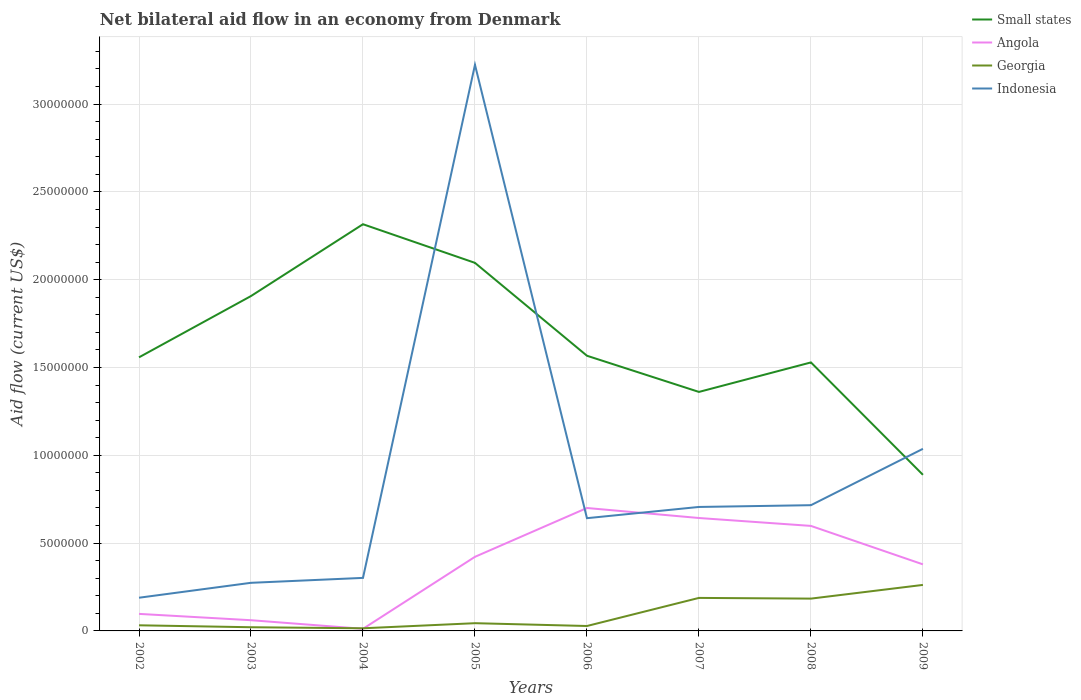Does the line corresponding to Angola intersect with the line corresponding to Small states?
Your answer should be compact. No. Across all years, what is the maximum net bilateral aid flow in Indonesia?
Provide a succinct answer. 1.89e+06. In which year was the net bilateral aid flow in Georgia maximum?
Provide a succinct answer. 2004. What is the total net bilateral aid flow in Angola in the graph?
Offer a very short reply. -5.86e+06. What is the difference between the highest and the second highest net bilateral aid flow in Indonesia?
Make the answer very short. 3.04e+07. How many lines are there?
Give a very brief answer. 4. How many years are there in the graph?
Give a very brief answer. 8. What is the difference between two consecutive major ticks on the Y-axis?
Provide a short and direct response. 5.00e+06. Does the graph contain grids?
Provide a succinct answer. Yes. What is the title of the graph?
Keep it short and to the point. Net bilateral aid flow in an economy from Denmark. Does "Comoros" appear as one of the legend labels in the graph?
Provide a short and direct response. No. What is the Aid flow (current US$) of Small states in 2002?
Ensure brevity in your answer.  1.56e+07. What is the Aid flow (current US$) of Angola in 2002?
Make the answer very short. 9.70e+05. What is the Aid flow (current US$) in Indonesia in 2002?
Your answer should be very brief. 1.89e+06. What is the Aid flow (current US$) in Small states in 2003?
Keep it short and to the point. 1.91e+07. What is the Aid flow (current US$) of Angola in 2003?
Your answer should be very brief. 6.10e+05. What is the Aid flow (current US$) of Georgia in 2003?
Offer a very short reply. 2.10e+05. What is the Aid flow (current US$) in Indonesia in 2003?
Offer a very short reply. 2.74e+06. What is the Aid flow (current US$) of Small states in 2004?
Keep it short and to the point. 2.32e+07. What is the Aid flow (current US$) of Angola in 2004?
Give a very brief answer. 1.20e+05. What is the Aid flow (current US$) in Georgia in 2004?
Provide a short and direct response. 1.50e+05. What is the Aid flow (current US$) of Indonesia in 2004?
Make the answer very short. 3.02e+06. What is the Aid flow (current US$) of Small states in 2005?
Your answer should be very brief. 2.10e+07. What is the Aid flow (current US$) in Angola in 2005?
Provide a short and direct response. 4.22e+06. What is the Aid flow (current US$) in Indonesia in 2005?
Ensure brevity in your answer.  3.22e+07. What is the Aid flow (current US$) in Small states in 2006?
Provide a short and direct response. 1.57e+07. What is the Aid flow (current US$) in Indonesia in 2006?
Provide a short and direct response. 6.42e+06. What is the Aid flow (current US$) of Small states in 2007?
Give a very brief answer. 1.36e+07. What is the Aid flow (current US$) of Angola in 2007?
Provide a short and direct response. 6.43e+06. What is the Aid flow (current US$) of Georgia in 2007?
Give a very brief answer. 1.88e+06. What is the Aid flow (current US$) of Indonesia in 2007?
Offer a terse response. 7.06e+06. What is the Aid flow (current US$) in Small states in 2008?
Provide a short and direct response. 1.53e+07. What is the Aid flow (current US$) of Angola in 2008?
Give a very brief answer. 5.98e+06. What is the Aid flow (current US$) in Georgia in 2008?
Provide a succinct answer. 1.84e+06. What is the Aid flow (current US$) of Indonesia in 2008?
Give a very brief answer. 7.16e+06. What is the Aid flow (current US$) in Small states in 2009?
Your answer should be very brief. 8.89e+06. What is the Aid flow (current US$) in Angola in 2009?
Provide a short and direct response. 3.79e+06. What is the Aid flow (current US$) of Georgia in 2009?
Your response must be concise. 2.62e+06. What is the Aid flow (current US$) of Indonesia in 2009?
Your answer should be very brief. 1.04e+07. Across all years, what is the maximum Aid flow (current US$) of Small states?
Provide a short and direct response. 2.32e+07. Across all years, what is the maximum Aid flow (current US$) of Angola?
Provide a succinct answer. 7.00e+06. Across all years, what is the maximum Aid flow (current US$) in Georgia?
Keep it short and to the point. 2.62e+06. Across all years, what is the maximum Aid flow (current US$) of Indonesia?
Your answer should be very brief. 3.22e+07. Across all years, what is the minimum Aid flow (current US$) in Small states?
Offer a very short reply. 8.89e+06. Across all years, what is the minimum Aid flow (current US$) in Angola?
Provide a short and direct response. 1.20e+05. Across all years, what is the minimum Aid flow (current US$) in Georgia?
Provide a succinct answer. 1.50e+05. Across all years, what is the minimum Aid flow (current US$) of Indonesia?
Your answer should be compact. 1.89e+06. What is the total Aid flow (current US$) of Small states in the graph?
Your answer should be very brief. 1.32e+08. What is the total Aid flow (current US$) in Angola in the graph?
Your answer should be very brief. 2.91e+07. What is the total Aid flow (current US$) of Georgia in the graph?
Provide a succinct answer. 7.74e+06. What is the total Aid flow (current US$) of Indonesia in the graph?
Keep it short and to the point. 7.09e+07. What is the difference between the Aid flow (current US$) of Small states in 2002 and that in 2003?
Your response must be concise. -3.49e+06. What is the difference between the Aid flow (current US$) of Georgia in 2002 and that in 2003?
Your answer should be compact. 1.10e+05. What is the difference between the Aid flow (current US$) of Indonesia in 2002 and that in 2003?
Give a very brief answer. -8.50e+05. What is the difference between the Aid flow (current US$) in Small states in 2002 and that in 2004?
Give a very brief answer. -7.58e+06. What is the difference between the Aid flow (current US$) of Angola in 2002 and that in 2004?
Offer a terse response. 8.50e+05. What is the difference between the Aid flow (current US$) of Georgia in 2002 and that in 2004?
Your answer should be very brief. 1.70e+05. What is the difference between the Aid flow (current US$) of Indonesia in 2002 and that in 2004?
Your response must be concise. -1.13e+06. What is the difference between the Aid flow (current US$) of Small states in 2002 and that in 2005?
Provide a succinct answer. -5.38e+06. What is the difference between the Aid flow (current US$) of Angola in 2002 and that in 2005?
Offer a very short reply. -3.25e+06. What is the difference between the Aid flow (current US$) of Georgia in 2002 and that in 2005?
Offer a very short reply. -1.20e+05. What is the difference between the Aid flow (current US$) of Indonesia in 2002 and that in 2005?
Your answer should be compact. -3.04e+07. What is the difference between the Aid flow (current US$) in Angola in 2002 and that in 2006?
Your answer should be compact. -6.03e+06. What is the difference between the Aid flow (current US$) of Indonesia in 2002 and that in 2006?
Make the answer very short. -4.53e+06. What is the difference between the Aid flow (current US$) in Small states in 2002 and that in 2007?
Keep it short and to the point. 1.97e+06. What is the difference between the Aid flow (current US$) of Angola in 2002 and that in 2007?
Your response must be concise. -5.46e+06. What is the difference between the Aid flow (current US$) of Georgia in 2002 and that in 2007?
Your response must be concise. -1.56e+06. What is the difference between the Aid flow (current US$) in Indonesia in 2002 and that in 2007?
Your response must be concise. -5.17e+06. What is the difference between the Aid flow (current US$) in Angola in 2002 and that in 2008?
Your answer should be compact. -5.01e+06. What is the difference between the Aid flow (current US$) of Georgia in 2002 and that in 2008?
Offer a terse response. -1.52e+06. What is the difference between the Aid flow (current US$) in Indonesia in 2002 and that in 2008?
Provide a succinct answer. -5.27e+06. What is the difference between the Aid flow (current US$) in Small states in 2002 and that in 2009?
Your answer should be compact. 6.69e+06. What is the difference between the Aid flow (current US$) in Angola in 2002 and that in 2009?
Offer a very short reply. -2.82e+06. What is the difference between the Aid flow (current US$) in Georgia in 2002 and that in 2009?
Offer a very short reply. -2.30e+06. What is the difference between the Aid flow (current US$) of Indonesia in 2002 and that in 2009?
Give a very brief answer. -8.48e+06. What is the difference between the Aid flow (current US$) in Small states in 2003 and that in 2004?
Offer a very short reply. -4.09e+06. What is the difference between the Aid flow (current US$) of Angola in 2003 and that in 2004?
Your answer should be compact. 4.90e+05. What is the difference between the Aid flow (current US$) in Georgia in 2003 and that in 2004?
Offer a very short reply. 6.00e+04. What is the difference between the Aid flow (current US$) in Indonesia in 2003 and that in 2004?
Your response must be concise. -2.80e+05. What is the difference between the Aid flow (current US$) of Small states in 2003 and that in 2005?
Keep it short and to the point. -1.89e+06. What is the difference between the Aid flow (current US$) in Angola in 2003 and that in 2005?
Ensure brevity in your answer.  -3.61e+06. What is the difference between the Aid flow (current US$) in Georgia in 2003 and that in 2005?
Offer a very short reply. -2.30e+05. What is the difference between the Aid flow (current US$) in Indonesia in 2003 and that in 2005?
Provide a short and direct response. -2.95e+07. What is the difference between the Aid flow (current US$) of Small states in 2003 and that in 2006?
Give a very brief answer. 3.40e+06. What is the difference between the Aid flow (current US$) of Angola in 2003 and that in 2006?
Give a very brief answer. -6.39e+06. What is the difference between the Aid flow (current US$) of Georgia in 2003 and that in 2006?
Provide a short and direct response. -7.00e+04. What is the difference between the Aid flow (current US$) in Indonesia in 2003 and that in 2006?
Ensure brevity in your answer.  -3.68e+06. What is the difference between the Aid flow (current US$) of Small states in 2003 and that in 2007?
Provide a short and direct response. 5.46e+06. What is the difference between the Aid flow (current US$) in Angola in 2003 and that in 2007?
Ensure brevity in your answer.  -5.82e+06. What is the difference between the Aid flow (current US$) in Georgia in 2003 and that in 2007?
Provide a short and direct response. -1.67e+06. What is the difference between the Aid flow (current US$) of Indonesia in 2003 and that in 2007?
Offer a very short reply. -4.32e+06. What is the difference between the Aid flow (current US$) in Small states in 2003 and that in 2008?
Your answer should be very brief. 3.78e+06. What is the difference between the Aid flow (current US$) in Angola in 2003 and that in 2008?
Give a very brief answer. -5.37e+06. What is the difference between the Aid flow (current US$) in Georgia in 2003 and that in 2008?
Ensure brevity in your answer.  -1.63e+06. What is the difference between the Aid flow (current US$) in Indonesia in 2003 and that in 2008?
Give a very brief answer. -4.42e+06. What is the difference between the Aid flow (current US$) of Small states in 2003 and that in 2009?
Keep it short and to the point. 1.02e+07. What is the difference between the Aid flow (current US$) of Angola in 2003 and that in 2009?
Offer a terse response. -3.18e+06. What is the difference between the Aid flow (current US$) in Georgia in 2003 and that in 2009?
Your response must be concise. -2.41e+06. What is the difference between the Aid flow (current US$) in Indonesia in 2003 and that in 2009?
Keep it short and to the point. -7.63e+06. What is the difference between the Aid flow (current US$) of Small states in 2004 and that in 2005?
Keep it short and to the point. 2.20e+06. What is the difference between the Aid flow (current US$) in Angola in 2004 and that in 2005?
Make the answer very short. -4.10e+06. What is the difference between the Aid flow (current US$) in Georgia in 2004 and that in 2005?
Keep it short and to the point. -2.90e+05. What is the difference between the Aid flow (current US$) in Indonesia in 2004 and that in 2005?
Give a very brief answer. -2.92e+07. What is the difference between the Aid flow (current US$) in Small states in 2004 and that in 2006?
Keep it short and to the point. 7.49e+06. What is the difference between the Aid flow (current US$) of Angola in 2004 and that in 2006?
Your answer should be compact. -6.88e+06. What is the difference between the Aid flow (current US$) in Indonesia in 2004 and that in 2006?
Offer a very short reply. -3.40e+06. What is the difference between the Aid flow (current US$) in Small states in 2004 and that in 2007?
Your response must be concise. 9.55e+06. What is the difference between the Aid flow (current US$) of Angola in 2004 and that in 2007?
Provide a succinct answer. -6.31e+06. What is the difference between the Aid flow (current US$) in Georgia in 2004 and that in 2007?
Your response must be concise. -1.73e+06. What is the difference between the Aid flow (current US$) in Indonesia in 2004 and that in 2007?
Offer a very short reply. -4.04e+06. What is the difference between the Aid flow (current US$) of Small states in 2004 and that in 2008?
Your answer should be compact. 7.87e+06. What is the difference between the Aid flow (current US$) of Angola in 2004 and that in 2008?
Offer a very short reply. -5.86e+06. What is the difference between the Aid flow (current US$) of Georgia in 2004 and that in 2008?
Offer a terse response. -1.69e+06. What is the difference between the Aid flow (current US$) of Indonesia in 2004 and that in 2008?
Keep it short and to the point. -4.14e+06. What is the difference between the Aid flow (current US$) in Small states in 2004 and that in 2009?
Ensure brevity in your answer.  1.43e+07. What is the difference between the Aid flow (current US$) in Angola in 2004 and that in 2009?
Keep it short and to the point. -3.67e+06. What is the difference between the Aid flow (current US$) of Georgia in 2004 and that in 2009?
Provide a succinct answer. -2.47e+06. What is the difference between the Aid flow (current US$) of Indonesia in 2004 and that in 2009?
Provide a succinct answer. -7.35e+06. What is the difference between the Aid flow (current US$) in Small states in 2005 and that in 2006?
Your response must be concise. 5.29e+06. What is the difference between the Aid flow (current US$) of Angola in 2005 and that in 2006?
Give a very brief answer. -2.78e+06. What is the difference between the Aid flow (current US$) in Georgia in 2005 and that in 2006?
Give a very brief answer. 1.60e+05. What is the difference between the Aid flow (current US$) in Indonesia in 2005 and that in 2006?
Provide a succinct answer. 2.58e+07. What is the difference between the Aid flow (current US$) in Small states in 2005 and that in 2007?
Offer a very short reply. 7.35e+06. What is the difference between the Aid flow (current US$) in Angola in 2005 and that in 2007?
Give a very brief answer. -2.21e+06. What is the difference between the Aid flow (current US$) in Georgia in 2005 and that in 2007?
Your answer should be very brief. -1.44e+06. What is the difference between the Aid flow (current US$) of Indonesia in 2005 and that in 2007?
Provide a short and direct response. 2.52e+07. What is the difference between the Aid flow (current US$) of Small states in 2005 and that in 2008?
Provide a succinct answer. 5.67e+06. What is the difference between the Aid flow (current US$) of Angola in 2005 and that in 2008?
Provide a succinct answer. -1.76e+06. What is the difference between the Aid flow (current US$) of Georgia in 2005 and that in 2008?
Provide a short and direct response. -1.40e+06. What is the difference between the Aid flow (current US$) in Indonesia in 2005 and that in 2008?
Give a very brief answer. 2.51e+07. What is the difference between the Aid flow (current US$) of Small states in 2005 and that in 2009?
Offer a very short reply. 1.21e+07. What is the difference between the Aid flow (current US$) in Angola in 2005 and that in 2009?
Keep it short and to the point. 4.30e+05. What is the difference between the Aid flow (current US$) in Georgia in 2005 and that in 2009?
Ensure brevity in your answer.  -2.18e+06. What is the difference between the Aid flow (current US$) in Indonesia in 2005 and that in 2009?
Give a very brief answer. 2.19e+07. What is the difference between the Aid flow (current US$) of Small states in 2006 and that in 2007?
Your answer should be very brief. 2.06e+06. What is the difference between the Aid flow (current US$) in Angola in 2006 and that in 2007?
Give a very brief answer. 5.70e+05. What is the difference between the Aid flow (current US$) of Georgia in 2006 and that in 2007?
Ensure brevity in your answer.  -1.60e+06. What is the difference between the Aid flow (current US$) in Indonesia in 2006 and that in 2007?
Give a very brief answer. -6.40e+05. What is the difference between the Aid flow (current US$) of Angola in 2006 and that in 2008?
Give a very brief answer. 1.02e+06. What is the difference between the Aid flow (current US$) of Georgia in 2006 and that in 2008?
Give a very brief answer. -1.56e+06. What is the difference between the Aid flow (current US$) of Indonesia in 2006 and that in 2008?
Provide a short and direct response. -7.40e+05. What is the difference between the Aid flow (current US$) of Small states in 2006 and that in 2009?
Your response must be concise. 6.78e+06. What is the difference between the Aid flow (current US$) in Angola in 2006 and that in 2009?
Provide a succinct answer. 3.21e+06. What is the difference between the Aid flow (current US$) in Georgia in 2006 and that in 2009?
Make the answer very short. -2.34e+06. What is the difference between the Aid flow (current US$) in Indonesia in 2006 and that in 2009?
Your answer should be compact. -3.95e+06. What is the difference between the Aid flow (current US$) in Small states in 2007 and that in 2008?
Make the answer very short. -1.68e+06. What is the difference between the Aid flow (current US$) of Small states in 2007 and that in 2009?
Your response must be concise. 4.72e+06. What is the difference between the Aid flow (current US$) of Angola in 2007 and that in 2009?
Offer a terse response. 2.64e+06. What is the difference between the Aid flow (current US$) of Georgia in 2007 and that in 2009?
Your answer should be very brief. -7.40e+05. What is the difference between the Aid flow (current US$) of Indonesia in 2007 and that in 2009?
Provide a succinct answer. -3.31e+06. What is the difference between the Aid flow (current US$) of Small states in 2008 and that in 2009?
Ensure brevity in your answer.  6.40e+06. What is the difference between the Aid flow (current US$) of Angola in 2008 and that in 2009?
Ensure brevity in your answer.  2.19e+06. What is the difference between the Aid flow (current US$) of Georgia in 2008 and that in 2009?
Provide a succinct answer. -7.80e+05. What is the difference between the Aid flow (current US$) in Indonesia in 2008 and that in 2009?
Provide a succinct answer. -3.21e+06. What is the difference between the Aid flow (current US$) in Small states in 2002 and the Aid flow (current US$) in Angola in 2003?
Your response must be concise. 1.50e+07. What is the difference between the Aid flow (current US$) in Small states in 2002 and the Aid flow (current US$) in Georgia in 2003?
Give a very brief answer. 1.54e+07. What is the difference between the Aid flow (current US$) of Small states in 2002 and the Aid flow (current US$) of Indonesia in 2003?
Offer a terse response. 1.28e+07. What is the difference between the Aid flow (current US$) of Angola in 2002 and the Aid flow (current US$) of Georgia in 2003?
Your answer should be compact. 7.60e+05. What is the difference between the Aid flow (current US$) of Angola in 2002 and the Aid flow (current US$) of Indonesia in 2003?
Keep it short and to the point. -1.77e+06. What is the difference between the Aid flow (current US$) in Georgia in 2002 and the Aid flow (current US$) in Indonesia in 2003?
Give a very brief answer. -2.42e+06. What is the difference between the Aid flow (current US$) in Small states in 2002 and the Aid flow (current US$) in Angola in 2004?
Keep it short and to the point. 1.55e+07. What is the difference between the Aid flow (current US$) in Small states in 2002 and the Aid flow (current US$) in Georgia in 2004?
Ensure brevity in your answer.  1.54e+07. What is the difference between the Aid flow (current US$) of Small states in 2002 and the Aid flow (current US$) of Indonesia in 2004?
Keep it short and to the point. 1.26e+07. What is the difference between the Aid flow (current US$) in Angola in 2002 and the Aid flow (current US$) in Georgia in 2004?
Provide a succinct answer. 8.20e+05. What is the difference between the Aid flow (current US$) in Angola in 2002 and the Aid flow (current US$) in Indonesia in 2004?
Your response must be concise. -2.05e+06. What is the difference between the Aid flow (current US$) in Georgia in 2002 and the Aid flow (current US$) in Indonesia in 2004?
Provide a short and direct response. -2.70e+06. What is the difference between the Aid flow (current US$) of Small states in 2002 and the Aid flow (current US$) of Angola in 2005?
Keep it short and to the point. 1.14e+07. What is the difference between the Aid flow (current US$) of Small states in 2002 and the Aid flow (current US$) of Georgia in 2005?
Offer a very short reply. 1.51e+07. What is the difference between the Aid flow (current US$) in Small states in 2002 and the Aid flow (current US$) in Indonesia in 2005?
Your answer should be compact. -1.67e+07. What is the difference between the Aid flow (current US$) in Angola in 2002 and the Aid flow (current US$) in Georgia in 2005?
Provide a succinct answer. 5.30e+05. What is the difference between the Aid flow (current US$) in Angola in 2002 and the Aid flow (current US$) in Indonesia in 2005?
Your response must be concise. -3.13e+07. What is the difference between the Aid flow (current US$) of Georgia in 2002 and the Aid flow (current US$) of Indonesia in 2005?
Make the answer very short. -3.19e+07. What is the difference between the Aid flow (current US$) in Small states in 2002 and the Aid flow (current US$) in Angola in 2006?
Offer a very short reply. 8.58e+06. What is the difference between the Aid flow (current US$) in Small states in 2002 and the Aid flow (current US$) in Georgia in 2006?
Ensure brevity in your answer.  1.53e+07. What is the difference between the Aid flow (current US$) of Small states in 2002 and the Aid flow (current US$) of Indonesia in 2006?
Give a very brief answer. 9.16e+06. What is the difference between the Aid flow (current US$) in Angola in 2002 and the Aid flow (current US$) in Georgia in 2006?
Keep it short and to the point. 6.90e+05. What is the difference between the Aid flow (current US$) of Angola in 2002 and the Aid flow (current US$) of Indonesia in 2006?
Make the answer very short. -5.45e+06. What is the difference between the Aid flow (current US$) in Georgia in 2002 and the Aid flow (current US$) in Indonesia in 2006?
Give a very brief answer. -6.10e+06. What is the difference between the Aid flow (current US$) in Small states in 2002 and the Aid flow (current US$) in Angola in 2007?
Give a very brief answer. 9.15e+06. What is the difference between the Aid flow (current US$) of Small states in 2002 and the Aid flow (current US$) of Georgia in 2007?
Keep it short and to the point. 1.37e+07. What is the difference between the Aid flow (current US$) in Small states in 2002 and the Aid flow (current US$) in Indonesia in 2007?
Make the answer very short. 8.52e+06. What is the difference between the Aid flow (current US$) in Angola in 2002 and the Aid flow (current US$) in Georgia in 2007?
Your response must be concise. -9.10e+05. What is the difference between the Aid flow (current US$) in Angola in 2002 and the Aid flow (current US$) in Indonesia in 2007?
Offer a terse response. -6.09e+06. What is the difference between the Aid flow (current US$) of Georgia in 2002 and the Aid flow (current US$) of Indonesia in 2007?
Ensure brevity in your answer.  -6.74e+06. What is the difference between the Aid flow (current US$) in Small states in 2002 and the Aid flow (current US$) in Angola in 2008?
Offer a terse response. 9.60e+06. What is the difference between the Aid flow (current US$) in Small states in 2002 and the Aid flow (current US$) in Georgia in 2008?
Provide a succinct answer. 1.37e+07. What is the difference between the Aid flow (current US$) of Small states in 2002 and the Aid flow (current US$) of Indonesia in 2008?
Offer a very short reply. 8.42e+06. What is the difference between the Aid flow (current US$) of Angola in 2002 and the Aid flow (current US$) of Georgia in 2008?
Offer a very short reply. -8.70e+05. What is the difference between the Aid flow (current US$) in Angola in 2002 and the Aid flow (current US$) in Indonesia in 2008?
Provide a succinct answer. -6.19e+06. What is the difference between the Aid flow (current US$) in Georgia in 2002 and the Aid flow (current US$) in Indonesia in 2008?
Make the answer very short. -6.84e+06. What is the difference between the Aid flow (current US$) of Small states in 2002 and the Aid flow (current US$) of Angola in 2009?
Provide a short and direct response. 1.18e+07. What is the difference between the Aid flow (current US$) in Small states in 2002 and the Aid flow (current US$) in Georgia in 2009?
Provide a succinct answer. 1.30e+07. What is the difference between the Aid flow (current US$) of Small states in 2002 and the Aid flow (current US$) of Indonesia in 2009?
Ensure brevity in your answer.  5.21e+06. What is the difference between the Aid flow (current US$) of Angola in 2002 and the Aid flow (current US$) of Georgia in 2009?
Keep it short and to the point. -1.65e+06. What is the difference between the Aid flow (current US$) in Angola in 2002 and the Aid flow (current US$) in Indonesia in 2009?
Your answer should be compact. -9.40e+06. What is the difference between the Aid flow (current US$) in Georgia in 2002 and the Aid flow (current US$) in Indonesia in 2009?
Your answer should be compact. -1.00e+07. What is the difference between the Aid flow (current US$) of Small states in 2003 and the Aid flow (current US$) of Angola in 2004?
Ensure brevity in your answer.  1.90e+07. What is the difference between the Aid flow (current US$) of Small states in 2003 and the Aid flow (current US$) of Georgia in 2004?
Your response must be concise. 1.89e+07. What is the difference between the Aid flow (current US$) of Small states in 2003 and the Aid flow (current US$) of Indonesia in 2004?
Your answer should be compact. 1.60e+07. What is the difference between the Aid flow (current US$) of Angola in 2003 and the Aid flow (current US$) of Indonesia in 2004?
Provide a short and direct response. -2.41e+06. What is the difference between the Aid flow (current US$) in Georgia in 2003 and the Aid flow (current US$) in Indonesia in 2004?
Your answer should be compact. -2.81e+06. What is the difference between the Aid flow (current US$) in Small states in 2003 and the Aid flow (current US$) in Angola in 2005?
Provide a short and direct response. 1.48e+07. What is the difference between the Aid flow (current US$) of Small states in 2003 and the Aid flow (current US$) of Georgia in 2005?
Your answer should be very brief. 1.86e+07. What is the difference between the Aid flow (current US$) of Small states in 2003 and the Aid flow (current US$) of Indonesia in 2005?
Provide a succinct answer. -1.32e+07. What is the difference between the Aid flow (current US$) of Angola in 2003 and the Aid flow (current US$) of Georgia in 2005?
Give a very brief answer. 1.70e+05. What is the difference between the Aid flow (current US$) in Angola in 2003 and the Aid flow (current US$) in Indonesia in 2005?
Your response must be concise. -3.16e+07. What is the difference between the Aid flow (current US$) of Georgia in 2003 and the Aid flow (current US$) of Indonesia in 2005?
Give a very brief answer. -3.20e+07. What is the difference between the Aid flow (current US$) in Small states in 2003 and the Aid flow (current US$) in Angola in 2006?
Provide a short and direct response. 1.21e+07. What is the difference between the Aid flow (current US$) of Small states in 2003 and the Aid flow (current US$) of Georgia in 2006?
Your answer should be compact. 1.88e+07. What is the difference between the Aid flow (current US$) in Small states in 2003 and the Aid flow (current US$) in Indonesia in 2006?
Your response must be concise. 1.26e+07. What is the difference between the Aid flow (current US$) in Angola in 2003 and the Aid flow (current US$) in Georgia in 2006?
Provide a short and direct response. 3.30e+05. What is the difference between the Aid flow (current US$) of Angola in 2003 and the Aid flow (current US$) of Indonesia in 2006?
Give a very brief answer. -5.81e+06. What is the difference between the Aid flow (current US$) of Georgia in 2003 and the Aid flow (current US$) of Indonesia in 2006?
Offer a terse response. -6.21e+06. What is the difference between the Aid flow (current US$) in Small states in 2003 and the Aid flow (current US$) in Angola in 2007?
Offer a terse response. 1.26e+07. What is the difference between the Aid flow (current US$) in Small states in 2003 and the Aid flow (current US$) in Georgia in 2007?
Provide a short and direct response. 1.72e+07. What is the difference between the Aid flow (current US$) in Small states in 2003 and the Aid flow (current US$) in Indonesia in 2007?
Offer a terse response. 1.20e+07. What is the difference between the Aid flow (current US$) in Angola in 2003 and the Aid flow (current US$) in Georgia in 2007?
Make the answer very short. -1.27e+06. What is the difference between the Aid flow (current US$) of Angola in 2003 and the Aid flow (current US$) of Indonesia in 2007?
Offer a very short reply. -6.45e+06. What is the difference between the Aid flow (current US$) in Georgia in 2003 and the Aid flow (current US$) in Indonesia in 2007?
Offer a terse response. -6.85e+06. What is the difference between the Aid flow (current US$) of Small states in 2003 and the Aid flow (current US$) of Angola in 2008?
Offer a terse response. 1.31e+07. What is the difference between the Aid flow (current US$) of Small states in 2003 and the Aid flow (current US$) of Georgia in 2008?
Give a very brief answer. 1.72e+07. What is the difference between the Aid flow (current US$) of Small states in 2003 and the Aid flow (current US$) of Indonesia in 2008?
Ensure brevity in your answer.  1.19e+07. What is the difference between the Aid flow (current US$) of Angola in 2003 and the Aid flow (current US$) of Georgia in 2008?
Keep it short and to the point. -1.23e+06. What is the difference between the Aid flow (current US$) of Angola in 2003 and the Aid flow (current US$) of Indonesia in 2008?
Your response must be concise. -6.55e+06. What is the difference between the Aid flow (current US$) of Georgia in 2003 and the Aid flow (current US$) of Indonesia in 2008?
Keep it short and to the point. -6.95e+06. What is the difference between the Aid flow (current US$) of Small states in 2003 and the Aid flow (current US$) of Angola in 2009?
Ensure brevity in your answer.  1.53e+07. What is the difference between the Aid flow (current US$) in Small states in 2003 and the Aid flow (current US$) in Georgia in 2009?
Provide a succinct answer. 1.64e+07. What is the difference between the Aid flow (current US$) of Small states in 2003 and the Aid flow (current US$) of Indonesia in 2009?
Your response must be concise. 8.70e+06. What is the difference between the Aid flow (current US$) of Angola in 2003 and the Aid flow (current US$) of Georgia in 2009?
Offer a terse response. -2.01e+06. What is the difference between the Aid flow (current US$) of Angola in 2003 and the Aid flow (current US$) of Indonesia in 2009?
Keep it short and to the point. -9.76e+06. What is the difference between the Aid flow (current US$) in Georgia in 2003 and the Aid flow (current US$) in Indonesia in 2009?
Ensure brevity in your answer.  -1.02e+07. What is the difference between the Aid flow (current US$) of Small states in 2004 and the Aid flow (current US$) of Angola in 2005?
Your answer should be compact. 1.89e+07. What is the difference between the Aid flow (current US$) of Small states in 2004 and the Aid flow (current US$) of Georgia in 2005?
Make the answer very short. 2.27e+07. What is the difference between the Aid flow (current US$) of Small states in 2004 and the Aid flow (current US$) of Indonesia in 2005?
Give a very brief answer. -9.08e+06. What is the difference between the Aid flow (current US$) of Angola in 2004 and the Aid flow (current US$) of Georgia in 2005?
Keep it short and to the point. -3.20e+05. What is the difference between the Aid flow (current US$) in Angola in 2004 and the Aid flow (current US$) in Indonesia in 2005?
Your answer should be compact. -3.21e+07. What is the difference between the Aid flow (current US$) in Georgia in 2004 and the Aid flow (current US$) in Indonesia in 2005?
Keep it short and to the point. -3.21e+07. What is the difference between the Aid flow (current US$) of Small states in 2004 and the Aid flow (current US$) of Angola in 2006?
Provide a succinct answer. 1.62e+07. What is the difference between the Aid flow (current US$) in Small states in 2004 and the Aid flow (current US$) in Georgia in 2006?
Keep it short and to the point. 2.29e+07. What is the difference between the Aid flow (current US$) in Small states in 2004 and the Aid flow (current US$) in Indonesia in 2006?
Make the answer very short. 1.67e+07. What is the difference between the Aid flow (current US$) of Angola in 2004 and the Aid flow (current US$) of Georgia in 2006?
Your response must be concise. -1.60e+05. What is the difference between the Aid flow (current US$) in Angola in 2004 and the Aid flow (current US$) in Indonesia in 2006?
Offer a terse response. -6.30e+06. What is the difference between the Aid flow (current US$) of Georgia in 2004 and the Aid flow (current US$) of Indonesia in 2006?
Your answer should be compact. -6.27e+06. What is the difference between the Aid flow (current US$) of Small states in 2004 and the Aid flow (current US$) of Angola in 2007?
Provide a short and direct response. 1.67e+07. What is the difference between the Aid flow (current US$) of Small states in 2004 and the Aid flow (current US$) of Georgia in 2007?
Your answer should be compact. 2.13e+07. What is the difference between the Aid flow (current US$) of Small states in 2004 and the Aid flow (current US$) of Indonesia in 2007?
Provide a succinct answer. 1.61e+07. What is the difference between the Aid flow (current US$) of Angola in 2004 and the Aid flow (current US$) of Georgia in 2007?
Provide a short and direct response. -1.76e+06. What is the difference between the Aid flow (current US$) in Angola in 2004 and the Aid flow (current US$) in Indonesia in 2007?
Give a very brief answer. -6.94e+06. What is the difference between the Aid flow (current US$) of Georgia in 2004 and the Aid flow (current US$) of Indonesia in 2007?
Offer a very short reply. -6.91e+06. What is the difference between the Aid flow (current US$) of Small states in 2004 and the Aid flow (current US$) of Angola in 2008?
Ensure brevity in your answer.  1.72e+07. What is the difference between the Aid flow (current US$) of Small states in 2004 and the Aid flow (current US$) of Georgia in 2008?
Your answer should be very brief. 2.13e+07. What is the difference between the Aid flow (current US$) of Small states in 2004 and the Aid flow (current US$) of Indonesia in 2008?
Your answer should be very brief. 1.60e+07. What is the difference between the Aid flow (current US$) in Angola in 2004 and the Aid flow (current US$) in Georgia in 2008?
Offer a very short reply. -1.72e+06. What is the difference between the Aid flow (current US$) in Angola in 2004 and the Aid flow (current US$) in Indonesia in 2008?
Provide a short and direct response. -7.04e+06. What is the difference between the Aid flow (current US$) in Georgia in 2004 and the Aid flow (current US$) in Indonesia in 2008?
Offer a terse response. -7.01e+06. What is the difference between the Aid flow (current US$) in Small states in 2004 and the Aid flow (current US$) in Angola in 2009?
Provide a short and direct response. 1.94e+07. What is the difference between the Aid flow (current US$) in Small states in 2004 and the Aid flow (current US$) in Georgia in 2009?
Ensure brevity in your answer.  2.05e+07. What is the difference between the Aid flow (current US$) in Small states in 2004 and the Aid flow (current US$) in Indonesia in 2009?
Provide a short and direct response. 1.28e+07. What is the difference between the Aid flow (current US$) of Angola in 2004 and the Aid flow (current US$) of Georgia in 2009?
Provide a succinct answer. -2.50e+06. What is the difference between the Aid flow (current US$) of Angola in 2004 and the Aid flow (current US$) of Indonesia in 2009?
Give a very brief answer. -1.02e+07. What is the difference between the Aid flow (current US$) of Georgia in 2004 and the Aid flow (current US$) of Indonesia in 2009?
Your response must be concise. -1.02e+07. What is the difference between the Aid flow (current US$) of Small states in 2005 and the Aid flow (current US$) of Angola in 2006?
Provide a succinct answer. 1.40e+07. What is the difference between the Aid flow (current US$) of Small states in 2005 and the Aid flow (current US$) of Georgia in 2006?
Ensure brevity in your answer.  2.07e+07. What is the difference between the Aid flow (current US$) in Small states in 2005 and the Aid flow (current US$) in Indonesia in 2006?
Give a very brief answer. 1.45e+07. What is the difference between the Aid flow (current US$) of Angola in 2005 and the Aid flow (current US$) of Georgia in 2006?
Your answer should be very brief. 3.94e+06. What is the difference between the Aid flow (current US$) in Angola in 2005 and the Aid flow (current US$) in Indonesia in 2006?
Keep it short and to the point. -2.20e+06. What is the difference between the Aid flow (current US$) of Georgia in 2005 and the Aid flow (current US$) of Indonesia in 2006?
Your answer should be compact. -5.98e+06. What is the difference between the Aid flow (current US$) of Small states in 2005 and the Aid flow (current US$) of Angola in 2007?
Your answer should be very brief. 1.45e+07. What is the difference between the Aid flow (current US$) of Small states in 2005 and the Aid flow (current US$) of Georgia in 2007?
Your response must be concise. 1.91e+07. What is the difference between the Aid flow (current US$) of Small states in 2005 and the Aid flow (current US$) of Indonesia in 2007?
Provide a succinct answer. 1.39e+07. What is the difference between the Aid flow (current US$) of Angola in 2005 and the Aid flow (current US$) of Georgia in 2007?
Provide a short and direct response. 2.34e+06. What is the difference between the Aid flow (current US$) of Angola in 2005 and the Aid flow (current US$) of Indonesia in 2007?
Your answer should be very brief. -2.84e+06. What is the difference between the Aid flow (current US$) in Georgia in 2005 and the Aid flow (current US$) in Indonesia in 2007?
Offer a terse response. -6.62e+06. What is the difference between the Aid flow (current US$) in Small states in 2005 and the Aid flow (current US$) in Angola in 2008?
Ensure brevity in your answer.  1.50e+07. What is the difference between the Aid flow (current US$) of Small states in 2005 and the Aid flow (current US$) of Georgia in 2008?
Provide a succinct answer. 1.91e+07. What is the difference between the Aid flow (current US$) in Small states in 2005 and the Aid flow (current US$) in Indonesia in 2008?
Make the answer very short. 1.38e+07. What is the difference between the Aid flow (current US$) in Angola in 2005 and the Aid flow (current US$) in Georgia in 2008?
Ensure brevity in your answer.  2.38e+06. What is the difference between the Aid flow (current US$) of Angola in 2005 and the Aid flow (current US$) of Indonesia in 2008?
Offer a very short reply. -2.94e+06. What is the difference between the Aid flow (current US$) of Georgia in 2005 and the Aid flow (current US$) of Indonesia in 2008?
Ensure brevity in your answer.  -6.72e+06. What is the difference between the Aid flow (current US$) in Small states in 2005 and the Aid flow (current US$) in Angola in 2009?
Your answer should be compact. 1.72e+07. What is the difference between the Aid flow (current US$) in Small states in 2005 and the Aid flow (current US$) in Georgia in 2009?
Your response must be concise. 1.83e+07. What is the difference between the Aid flow (current US$) of Small states in 2005 and the Aid flow (current US$) of Indonesia in 2009?
Ensure brevity in your answer.  1.06e+07. What is the difference between the Aid flow (current US$) in Angola in 2005 and the Aid flow (current US$) in Georgia in 2009?
Give a very brief answer. 1.60e+06. What is the difference between the Aid flow (current US$) of Angola in 2005 and the Aid flow (current US$) of Indonesia in 2009?
Provide a short and direct response. -6.15e+06. What is the difference between the Aid flow (current US$) of Georgia in 2005 and the Aid flow (current US$) of Indonesia in 2009?
Offer a terse response. -9.93e+06. What is the difference between the Aid flow (current US$) of Small states in 2006 and the Aid flow (current US$) of Angola in 2007?
Give a very brief answer. 9.24e+06. What is the difference between the Aid flow (current US$) in Small states in 2006 and the Aid flow (current US$) in Georgia in 2007?
Your answer should be very brief. 1.38e+07. What is the difference between the Aid flow (current US$) in Small states in 2006 and the Aid flow (current US$) in Indonesia in 2007?
Ensure brevity in your answer.  8.61e+06. What is the difference between the Aid flow (current US$) in Angola in 2006 and the Aid flow (current US$) in Georgia in 2007?
Give a very brief answer. 5.12e+06. What is the difference between the Aid flow (current US$) of Georgia in 2006 and the Aid flow (current US$) of Indonesia in 2007?
Your response must be concise. -6.78e+06. What is the difference between the Aid flow (current US$) in Small states in 2006 and the Aid flow (current US$) in Angola in 2008?
Offer a terse response. 9.69e+06. What is the difference between the Aid flow (current US$) of Small states in 2006 and the Aid flow (current US$) of Georgia in 2008?
Keep it short and to the point. 1.38e+07. What is the difference between the Aid flow (current US$) in Small states in 2006 and the Aid flow (current US$) in Indonesia in 2008?
Your response must be concise. 8.51e+06. What is the difference between the Aid flow (current US$) in Angola in 2006 and the Aid flow (current US$) in Georgia in 2008?
Provide a succinct answer. 5.16e+06. What is the difference between the Aid flow (current US$) of Angola in 2006 and the Aid flow (current US$) of Indonesia in 2008?
Offer a terse response. -1.60e+05. What is the difference between the Aid flow (current US$) of Georgia in 2006 and the Aid flow (current US$) of Indonesia in 2008?
Provide a succinct answer. -6.88e+06. What is the difference between the Aid flow (current US$) of Small states in 2006 and the Aid flow (current US$) of Angola in 2009?
Your response must be concise. 1.19e+07. What is the difference between the Aid flow (current US$) in Small states in 2006 and the Aid flow (current US$) in Georgia in 2009?
Your answer should be compact. 1.30e+07. What is the difference between the Aid flow (current US$) of Small states in 2006 and the Aid flow (current US$) of Indonesia in 2009?
Your answer should be very brief. 5.30e+06. What is the difference between the Aid flow (current US$) of Angola in 2006 and the Aid flow (current US$) of Georgia in 2009?
Give a very brief answer. 4.38e+06. What is the difference between the Aid flow (current US$) in Angola in 2006 and the Aid flow (current US$) in Indonesia in 2009?
Provide a succinct answer. -3.37e+06. What is the difference between the Aid flow (current US$) in Georgia in 2006 and the Aid flow (current US$) in Indonesia in 2009?
Offer a terse response. -1.01e+07. What is the difference between the Aid flow (current US$) of Small states in 2007 and the Aid flow (current US$) of Angola in 2008?
Your answer should be very brief. 7.63e+06. What is the difference between the Aid flow (current US$) in Small states in 2007 and the Aid flow (current US$) in Georgia in 2008?
Offer a terse response. 1.18e+07. What is the difference between the Aid flow (current US$) of Small states in 2007 and the Aid flow (current US$) of Indonesia in 2008?
Keep it short and to the point. 6.45e+06. What is the difference between the Aid flow (current US$) in Angola in 2007 and the Aid flow (current US$) in Georgia in 2008?
Your answer should be compact. 4.59e+06. What is the difference between the Aid flow (current US$) in Angola in 2007 and the Aid flow (current US$) in Indonesia in 2008?
Offer a very short reply. -7.30e+05. What is the difference between the Aid flow (current US$) of Georgia in 2007 and the Aid flow (current US$) of Indonesia in 2008?
Provide a succinct answer. -5.28e+06. What is the difference between the Aid flow (current US$) of Small states in 2007 and the Aid flow (current US$) of Angola in 2009?
Offer a terse response. 9.82e+06. What is the difference between the Aid flow (current US$) in Small states in 2007 and the Aid flow (current US$) in Georgia in 2009?
Your answer should be compact. 1.10e+07. What is the difference between the Aid flow (current US$) of Small states in 2007 and the Aid flow (current US$) of Indonesia in 2009?
Provide a short and direct response. 3.24e+06. What is the difference between the Aid flow (current US$) of Angola in 2007 and the Aid flow (current US$) of Georgia in 2009?
Give a very brief answer. 3.81e+06. What is the difference between the Aid flow (current US$) in Angola in 2007 and the Aid flow (current US$) in Indonesia in 2009?
Keep it short and to the point. -3.94e+06. What is the difference between the Aid flow (current US$) in Georgia in 2007 and the Aid flow (current US$) in Indonesia in 2009?
Keep it short and to the point. -8.49e+06. What is the difference between the Aid flow (current US$) of Small states in 2008 and the Aid flow (current US$) of Angola in 2009?
Make the answer very short. 1.15e+07. What is the difference between the Aid flow (current US$) of Small states in 2008 and the Aid flow (current US$) of Georgia in 2009?
Keep it short and to the point. 1.27e+07. What is the difference between the Aid flow (current US$) of Small states in 2008 and the Aid flow (current US$) of Indonesia in 2009?
Ensure brevity in your answer.  4.92e+06. What is the difference between the Aid flow (current US$) of Angola in 2008 and the Aid flow (current US$) of Georgia in 2009?
Provide a short and direct response. 3.36e+06. What is the difference between the Aid flow (current US$) in Angola in 2008 and the Aid flow (current US$) in Indonesia in 2009?
Offer a terse response. -4.39e+06. What is the difference between the Aid flow (current US$) of Georgia in 2008 and the Aid flow (current US$) of Indonesia in 2009?
Offer a terse response. -8.53e+06. What is the average Aid flow (current US$) in Small states per year?
Keep it short and to the point. 1.65e+07. What is the average Aid flow (current US$) of Angola per year?
Keep it short and to the point. 3.64e+06. What is the average Aid flow (current US$) of Georgia per year?
Keep it short and to the point. 9.68e+05. What is the average Aid flow (current US$) in Indonesia per year?
Offer a very short reply. 8.86e+06. In the year 2002, what is the difference between the Aid flow (current US$) of Small states and Aid flow (current US$) of Angola?
Give a very brief answer. 1.46e+07. In the year 2002, what is the difference between the Aid flow (current US$) in Small states and Aid flow (current US$) in Georgia?
Offer a terse response. 1.53e+07. In the year 2002, what is the difference between the Aid flow (current US$) in Small states and Aid flow (current US$) in Indonesia?
Give a very brief answer. 1.37e+07. In the year 2002, what is the difference between the Aid flow (current US$) of Angola and Aid flow (current US$) of Georgia?
Your response must be concise. 6.50e+05. In the year 2002, what is the difference between the Aid flow (current US$) in Angola and Aid flow (current US$) in Indonesia?
Keep it short and to the point. -9.20e+05. In the year 2002, what is the difference between the Aid flow (current US$) of Georgia and Aid flow (current US$) of Indonesia?
Provide a short and direct response. -1.57e+06. In the year 2003, what is the difference between the Aid flow (current US$) in Small states and Aid flow (current US$) in Angola?
Keep it short and to the point. 1.85e+07. In the year 2003, what is the difference between the Aid flow (current US$) of Small states and Aid flow (current US$) of Georgia?
Offer a terse response. 1.89e+07. In the year 2003, what is the difference between the Aid flow (current US$) of Small states and Aid flow (current US$) of Indonesia?
Make the answer very short. 1.63e+07. In the year 2003, what is the difference between the Aid flow (current US$) of Angola and Aid flow (current US$) of Georgia?
Give a very brief answer. 4.00e+05. In the year 2003, what is the difference between the Aid flow (current US$) of Angola and Aid flow (current US$) of Indonesia?
Offer a very short reply. -2.13e+06. In the year 2003, what is the difference between the Aid flow (current US$) of Georgia and Aid flow (current US$) of Indonesia?
Make the answer very short. -2.53e+06. In the year 2004, what is the difference between the Aid flow (current US$) of Small states and Aid flow (current US$) of Angola?
Your answer should be very brief. 2.30e+07. In the year 2004, what is the difference between the Aid flow (current US$) of Small states and Aid flow (current US$) of Georgia?
Keep it short and to the point. 2.30e+07. In the year 2004, what is the difference between the Aid flow (current US$) of Small states and Aid flow (current US$) of Indonesia?
Ensure brevity in your answer.  2.01e+07. In the year 2004, what is the difference between the Aid flow (current US$) in Angola and Aid flow (current US$) in Georgia?
Give a very brief answer. -3.00e+04. In the year 2004, what is the difference between the Aid flow (current US$) of Angola and Aid flow (current US$) of Indonesia?
Ensure brevity in your answer.  -2.90e+06. In the year 2004, what is the difference between the Aid flow (current US$) in Georgia and Aid flow (current US$) in Indonesia?
Keep it short and to the point. -2.87e+06. In the year 2005, what is the difference between the Aid flow (current US$) of Small states and Aid flow (current US$) of Angola?
Your answer should be compact. 1.67e+07. In the year 2005, what is the difference between the Aid flow (current US$) in Small states and Aid flow (current US$) in Georgia?
Offer a very short reply. 2.05e+07. In the year 2005, what is the difference between the Aid flow (current US$) of Small states and Aid flow (current US$) of Indonesia?
Make the answer very short. -1.13e+07. In the year 2005, what is the difference between the Aid flow (current US$) of Angola and Aid flow (current US$) of Georgia?
Offer a very short reply. 3.78e+06. In the year 2005, what is the difference between the Aid flow (current US$) in Angola and Aid flow (current US$) in Indonesia?
Offer a very short reply. -2.80e+07. In the year 2005, what is the difference between the Aid flow (current US$) in Georgia and Aid flow (current US$) in Indonesia?
Provide a succinct answer. -3.18e+07. In the year 2006, what is the difference between the Aid flow (current US$) in Small states and Aid flow (current US$) in Angola?
Give a very brief answer. 8.67e+06. In the year 2006, what is the difference between the Aid flow (current US$) in Small states and Aid flow (current US$) in Georgia?
Offer a terse response. 1.54e+07. In the year 2006, what is the difference between the Aid flow (current US$) of Small states and Aid flow (current US$) of Indonesia?
Provide a succinct answer. 9.25e+06. In the year 2006, what is the difference between the Aid flow (current US$) in Angola and Aid flow (current US$) in Georgia?
Your response must be concise. 6.72e+06. In the year 2006, what is the difference between the Aid flow (current US$) of Angola and Aid flow (current US$) of Indonesia?
Keep it short and to the point. 5.80e+05. In the year 2006, what is the difference between the Aid flow (current US$) in Georgia and Aid flow (current US$) in Indonesia?
Keep it short and to the point. -6.14e+06. In the year 2007, what is the difference between the Aid flow (current US$) in Small states and Aid flow (current US$) in Angola?
Offer a terse response. 7.18e+06. In the year 2007, what is the difference between the Aid flow (current US$) in Small states and Aid flow (current US$) in Georgia?
Your response must be concise. 1.17e+07. In the year 2007, what is the difference between the Aid flow (current US$) in Small states and Aid flow (current US$) in Indonesia?
Give a very brief answer. 6.55e+06. In the year 2007, what is the difference between the Aid flow (current US$) in Angola and Aid flow (current US$) in Georgia?
Offer a terse response. 4.55e+06. In the year 2007, what is the difference between the Aid flow (current US$) of Angola and Aid flow (current US$) of Indonesia?
Offer a very short reply. -6.30e+05. In the year 2007, what is the difference between the Aid flow (current US$) in Georgia and Aid flow (current US$) in Indonesia?
Ensure brevity in your answer.  -5.18e+06. In the year 2008, what is the difference between the Aid flow (current US$) of Small states and Aid flow (current US$) of Angola?
Make the answer very short. 9.31e+06. In the year 2008, what is the difference between the Aid flow (current US$) in Small states and Aid flow (current US$) in Georgia?
Provide a short and direct response. 1.34e+07. In the year 2008, what is the difference between the Aid flow (current US$) of Small states and Aid flow (current US$) of Indonesia?
Ensure brevity in your answer.  8.13e+06. In the year 2008, what is the difference between the Aid flow (current US$) of Angola and Aid flow (current US$) of Georgia?
Your answer should be very brief. 4.14e+06. In the year 2008, what is the difference between the Aid flow (current US$) in Angola and Aid flow (current US$) in Indonesia?
Provide a succinct answer. -1.18e+06. In the year 2008, what is the difference between the Aid flow (current US$) in Georgia and Aid flow (current US$) in Indonesia?
Provide a succinct answer. -5.32e+06. In the year 2009, what is the difference between the Aid flow (current US$) of Small states and Aid flow (current US$) of Angola?
Your answer should be very brief. 5.10e+06. In the year 2009, what is the difference between the Aid flow (current US$) in Small states and Aid flow (current US$) in Georgia?
Offer a very short reply. 6.27e+06. In the year 2009, what is the difference between the Aid flow (current US$) of Small states and Aid flow (current US$) of Indonesia?
Offer a very short reply. -1.48e+06. In the year 2009, what is the difference between the Aid flow (current US$) in Angola and Aid flow (current US$) in Georgia?
Give a very brief answer. 1.17e+06. In the year 2009, what is the difference between the Aid flow (current US$) of Angola and Aid flow (current US$) of Indonesia?
Your response must be concise. -6.58e+06. In the year 2009, what is the difference between the Aid flow (current US$) of Georgia and Aid flow (current US$) of Indonesia?
Your answer should be very brief. -7.75e+06. What is the ratio of the Aid flow (current US$) in Small states in 2002 to that in 2003?
Offer a very short reply. 0.82. What is the ratio of the Aid flow (current US$) of Angola in 2002 to that in 2003?
Keep it short and to the point. 1.59. What is the ratio of the Aid flow (current US$) of Georgia in 2002 to that in 2003?
Ensure brevity in your answer.  1.52. What is the ratio of the Aid flow (current US$) in Indonesia in 2002 to that in 2003?
Offer a very short reply. 0.69. What is the ratio of the Aid flow (current US$) of Small states in 2002 to that in 2004?
Ensure brevity in your answer.  0.67. What is the ratio of the Aid flow (current US$) of Angola in 2002 to that in 2004?
Keep it short and to the point. 8.08. What is the ratio of the Aid flow (current US$) of Georgia in 2002 to that in 2004?
Your answer should be compact. 2.13. What is the ratio of the Aid flow (current US$) in Indonesia in 2002 to that in 2004?
Your answer should be compact. 0.63. What is the ratio of the Aid flow (current US$) of Small states in 2002 to that in 2005?
Provide a short and direct response. 0.74. What is the ratio of the Aid flow (current US$) in Angola in 2002 to that in 2005?
Make the answer very short. 0.23. What is the ratio of the Aid flow (current US$) in Georgia in 2002 to that in 2005?
Keep it short and to the point. 0.73. What is the ratio of the Aid flow (current US$) in Indonesia in 2002 to that in 2005?
Provide a short and direct response. 0.06. What is the ratio of the Aid flow (current US$) in Angola in 2002 to that in 2006?
Make the answer very short. 0.14. What is the ratio of the Aid flow (current US$) in Indonesia in 2002 to that in 2006?
Your response must be concise. 0.29. What is the ratio of the Aid flow (current US$) in Small states in 2002 to that in 2007?
Offer a very short reply. 1.14. What is the ratio of the Aid flow (current US$) of Angola in 2002 to that in 2007?
Offer a terse response. 0.15. What is the ratio of the Aid flow (current US$) of Georgia in 2002 to that in 2007?
Your answer should be very brief. 0.17. What is the ratio of the Aid flow (current US$) in Indonesia in 2002 to that in 2007?
Provide a short and direct response. 0.27. What is the ratio of the Aid flow (current US$) of Angola in 2002 to that in 2008?
Offer a terse response. 0.16. What is the ratio of the Aid flow (current US$) in Georgia in 2002 to that in 2008?
Make the answer very short. 0.17. What is the ratio of the Aid flow (current US$) of Indonesia in 2002 to that in 2008?
Your answer should be compact. 0.26. What is the ratio of the Aid flow (current US$) in Small states in 2002 to that in 2009?
Make the answer very short. 1.75. What is the ratio of the Aid flow (current US$) of Angola in 2002 to that in 2009?
Your response must be concise. 0.26. What is the ratio of the Aid flow (current US$) in Georgia in 2002 to that in 2009?
Give a very brief answer. 0.12. What is the ratio of the Aid flow (current US$) in Indonesia in 2002 to that in 2009?
Provide a short and direct response. 0.18. What is the ratio of the Aid flow (current US$) of Small states in 2003 to that in 2004?
Provide a short and direct response. 0.82. What is the ratio of the Aid flow (current US$) of Angola in 2003 to that in 2004?
Provide a succinct answer. 5.08. What is the ratio of the Aid flow (current US$) of Indonesia in 2003 to that in 2004?
Provide a short and direct response. 0.91. What is the ratio of the Aid flow (current US$) of Small states in 2003 to that in 2005?
Provide a succinct answer. 0.91. What is the ratio of the Aid flow (current US$) of Angola in 2003 to that in 2005?
Ensure brevity in your answer.  0.14. What is the ratio of the Aid flow (current US$) of Georgia in 2003 to that in 2005?
Provide a succinct answer. 0.48. What is the ratio of the Aid flow (current US$) of Indonesia in 2003 to that in 2005?
Make the answer very short. 0.09. What is the ratio of the Aid flow (current US$) in Small states in 2003 to that in 2006?
Offer a terse response. 1.22. What is the ratio of the Aid flow (current US$) of Angola in 2003 to that in 2006?
Keep it short and to the point. 0.09. What is the ratio of the Aid flow (current US$) in Georgia in 2003 to that in 2006?
Your answer should be compact. 0.75. What is the ratio of the Aid flow (current US$) of Indonesia in 2003 to that in 2006?
Your response must be concise. 0.43. What is the ratio of the Aid flow (current US$) in Small states in 2003 to that in 2007?
Provide a short and direct response. 1.4. What is the ratio of the Aid flow (current US$) in Angola in 2003 to that in 2007?
Keep it short and to the point. 0.09. What is the ratio of the Aid flow (current US$) of Georgia in 2003 to that in 2007?
Give a very brief answer. 0.11. What is the ratio of the Aid flow (current US$) in Indonesia in 2003 to that in 2007?
Offer a very short reply. 0.39. What is the ratio of the Aid flow (current US$) of Small states in 2003 to that in 2008?
Offer a terse response. 1.25. What is the ratio of the Aid flow (current US$) of Angola in 2003 to that in 2008?
Your response must be concise. 0.1. What is the ratio of the Aid flow (current US$) of Georgia in 2003 to that in 2008?
Your response must be concise. 0.11. What is the ratio of the Aid flow (current US$) of Indonesia in 2003 to that in 2008?
Your answer should be very brief. 0.38. What is the ratio of the Aid flow (current US$) of Small states in 2003 to that in 2009?
Ensure brevity in your answer.  2.15. What is the ratio of the Aid flow (current US$) of Angola in 2003 to that in 2009?
Provide a short and direct response. 0.16. What is the ratio of the Aid flow (current US$) in Georgia in 2003 to that in 2009?
Your response must be concise. 0.08. What is the ratio of the Aid flow (current US$) of Indonesia in 2003 to that in 2009?
Offer a very short reply. 0.26. What is the ratio of the Aid flow (current US$) in Small states in 2004 to that in 2005?
Offer a very short reply. 1.1. What is the ratio of the Aid flow (current US$) of Angola in 2004 to that in 2005?
Your answer should be very brief. 0.03. What is the ratio of the Aid flow (current US$) in Georgia in 2004 to that in 2005?
Give a very brief answer. 0.34. What is the ratio of the Aid flow (current US$) in Indonesia in 2004 to that in 2005?
Offer a very short reply. 0.09. What is the ratio of the Aid flow (current US$) in Small states in 2004 to that in 2006?
Offer a very short reply. 1.48. What is the ratio of the Aid flow (current US$) of Angola in 2004 to that in 2006?
Your response must be concise. 0.02. What is the ratio of the Aid flow (current US$) of Georgia in 2004 to that in 2006?
Offer a very short reply. 0.54. What is the ratio of the Aid flow (current US$) in Indonesia in 2004 to that in 2006?
Provide a succinct answer. 0.47. What is the ratio of the Aid flow (current US$) in Small states in 2004 to that in 2007?
Ensure brevity in your answer.  1.7. What is the ratio of the Aid flow (current US$) in Angola in 2004 to that in 2007?
Give a very brief answer. 0.02. What is the ratio of the Aid flow (current US$) of Georgia in 2004 to that in 2007?
Keep it short and to the point. 0.08. What is the ratio of the Aid flow (current US$) in Indonesia in 2004 to that in 2007?
Ensure brevity in your answer.  0.43. What is the ratio of the Aid flow (current US$) of Small states in 2004 to that in 2008?
Offer a terse response. 1.51. What is the ratio of the Aid flow (current US$) of Angola in 2004 to that in 2008?
Ensure brevity in your answer.  0.02. What is the ratio of the Aid flow (current US$) in Georgia in 2004 to that in 2008?
Your answer should be compact. 0.08. What is the ratio of the Aid flow (current US$) in Indonesia in 2004 to that in 2008?
Provide a succinct answer. 0.42. What is the ratio of the Aid flow (current US$) of Small states in 2004 to that in 2009?
Ensure brevity in your answer.  2.61. What is the ratio of the Aid flow (current US$) in Angola in 2004 to that in 2009?
Make the answer very short. 0.03. What is the ratio of the Aid flow (current US$) in Georgia in 2004 to that in 2009?
Give a very brief answer. 0.06. What is the ratio of the Aid flow (current US$) of Indonesia in 2004 to that in 2009?
Keep it short and to the point. 0.29. What is the ratio of the Aid flow (current US$) of Small states in 2005 to that in 2006?
Give a very brief answer. 1.34. What is the ratio of the Aid flow (current US$) in Angola in 2005 to that in 2006?
Your answer should be very brief. 0.6. What is the ratio of the Aid flow (current US$) in Georgia in 2005 to that in 2006?
Your response must be concise. 1.57. What is the ratio of the Aid flow (current US$) in Indonesia in 2005 to that in 2006?
Your answer should be very brief. 5.02. What is the ratio of the Aid flow (current US$) in Small states in 2005 to that in 2007?
Make the answer very short. 1.54. What is the ratio of the Aid flow (current US$) in Angola in 2005 to that in 2007?
Keep it short and to the point. 0.66. What is the ratio of the Aid flow (current US$) of Georgia in 2005 to that in 2007?
Provide a short and direct response. 0.23. What is the ratio of the Aid flow (current US$) in Indonesia in 2005 to that in 2007?
Your answer should be very brief. 4.57. What is the ratio of the Aid flow (current US$) in Small states in 2005 to that in 2008?
Provide a short and direct response. 1.37. What is the ratio of the Aid flow (current US$) in Angola in 2005 to that in 2008?
Make the answer very short. 0.71. What is the ratio of the Aid flow (current US$) of Georgia in 2005 to that in 2008?
Provide a succinct answer. 0.24. What is the ratio of the Aid flow (current US$) in Indonesia in 2005 to that in 2008?
Ensure brevity in your answer.  4.5. What is the ratio of the Aid flow (current US$) of Small states in 2005 to that in 2009?
Provide a short and direct response. 2.36. What is the ratio of the Aid flow (current US$) of Angola in 2005 to that in 2009?
Your answer should be very brief. 1.11. What is the ratio of the Aid flow (current US$) of Georgia in 2005 to that in 2009?
Keep it short and to the point. 0.17. What is the ratio of the Aid flow (current US$) in Indonesia in 2005 to that in 2009?
Keep it short and to the point. 3.11. What is the ratio of the Aid flow (current US$) of Small states in 2006 to that in 2007?
Provide a succinct answer. 1.15. What is the ratio of the Aid flow (current US$) of Angola in 2006 to that in 2007?
Offer a terse response. 1.09. What is the ratio of the Aid flow (current US$) of Georgia in 2006 to that in 2007?
Make the answer very short. 0.15. What is the ratio of the Aid flow (current US$) of Indonesia in 2006 to that in 2007?
Offer a very short reply. 0.91. What is the ratio of the Aid flow (current US$) of Small states in 2006 to that in 2008?
Give a very brief answer. 1.02. What is the ratio of the Aid flow (current US$) in Angola in 2006 to that in 2008?
Provide a short and direct response. 1.17. What is the ratio of the Aid flow (current US$) in Georgia in 2006 to that in 2008?
Provide a succinct answer. 0.15. What is the ratio of the Aid flow (current US$) in Indonesia in 2006 to that in 2008?
Offer a terse response. 0.9. What is the ratio of the Aid flow (current US$) of Small states in 2006 to that in 2009?
Offer a very short reply. 1.76. What is the ratio of the Aid flow (current US$) of Angola in 2006 to that in 2009?
Your answer should be very brief. 1.85. What is the ratio of the Aid flow (current US$) in Georgia in 2006 to that in 2009?
Offer a very short reply. 0.11. What is the ratio of the Aid flow (current US$) of Indonesia in 2006 to that in 2009?
Provide a succinct answer. 0.62. What is the ratio of the Aid flow (current US$) in Small states in 2007 to that in 2008?
Offer a terse response. 0.89. What is the ratio of the Aid flow (current US$) of Angola in 2007 to that in 2008?
Make the answer very short. 1.08. What is the ratio of the Aid flow (current US$) in Georgia in 2007 to that in 2008?
Keep it short and to the point. 1.02. What is the ratio of the Aid flow (current US$) in Small states in 2007 to that in 2009?
Ensure brevity in your answer.  1.53. What is the ratio of the Aid flow (current US$) of Angola in 2007 to that in 2009?
Make the answer very short. 1.7. What is the ratio of the Aid flow (current US$) in Georgia in 2007 to that in 2009?
Provide a succinct answer. 0.72. What is the ratio of the Aid flow (current US$) in Indonesia in 2007 to that in 2009?
Make the answer very short. 0.68. What is the ratio of the Aid flow (current US$) of Small states in 2008 to that in 2009?
Provide a succinct answer. 1.72. What is the ratio of the Aid flow (current US$) of Angola in 2008 to that in 2009?
Your answer should be very brief. 1.58. What is the ratio of the Aid flow (current US$) of Georgia in 2008 to that in 2009?
Ensure brevity in your answer.  0.7. What is the ratio of the Aid flow (current US$) of Indonesia in 2008 to that in 2009?
Make the answer very short. 0.69. What is the difference between the highest and the second highest Aid flow (current US$) in Small states?
Your answer should be very brief. 2.20e+06. What is the difference between the highest and the second highest Aid flow (current US$) in Angola?
Provide a succinct answer. 5.70e+05. What is the difference between the highest and the second highest Aid flow (current US$) of Georgia?
Your answer should be compact. 7.40e+05. What is the difference between the highest and the second highest Aid flow (current US$) of Indonesia?
Keep it short and to the point. 2.19e+07. What is the difference between the highest and the lowest Aid flow (current US$) of Small states?
Provide a succinct answer. 1.43e+07. What is the difference between the highest and the lowest Aid flow (current US$) in Angola?
Provide a short and direct response. 6.88e+06. What is the difference between the highest and the lowest Aid flow (current US$) of Georgia?
Your answer should be compact. 2.47e+06. What is the difference between the highest and the lowest Aid flow (current US$) in Indonesia?
Provide a succinct answer. 3.04e+07. 